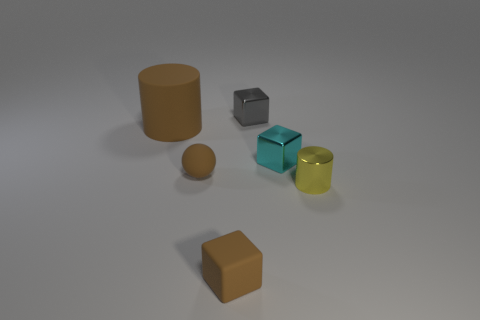Subtract all rubber blocks. How many blocks are left? 2 Add 3 rubber cylinders. How many objects exist? 9 Subtract all yellow cylinders. How many cylinders are left? 1 Subtract 2 cylinders. How many cylinders are left? 0 Subtract all cylinders. How many objects are left? 4 Subtract 0 red spheres. How many objects are left? 6 Subtract all cyan cylinders. Subtract all blue cubes. How many cylinders are left? 2 Subtract all balls. Subtract all brown rubber balls. How many objects are left? 4 Add 4 small matte blocks. How many small matte blocks are left? 5 Add 6 small brown objects. How many small brown objects exist? 8 